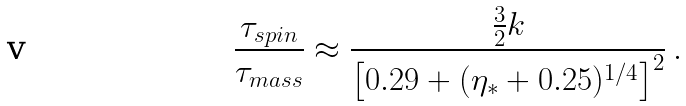<formula> <loc_0><loc_0><loc_500><loc_500>\frac { \tau _ { s p i n } } { \tau _ { m a s s } } \approx \frac { \frac { 3 } { 2 } k } { \left [ 0 . 2 9 + ( \eta _ { \ast } + 0 . 2 5 ) ^ { 1 / 4 } \right ] ^ { 2 } } \, .</formula> 